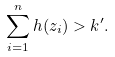Convert formula to latex. <formula><loc_0><loc_0><loc_500><loc_500>\sum _ { i = 1 } ^ { n } h ( z _ { i } ) > k ^ { \prime } .</formula> 